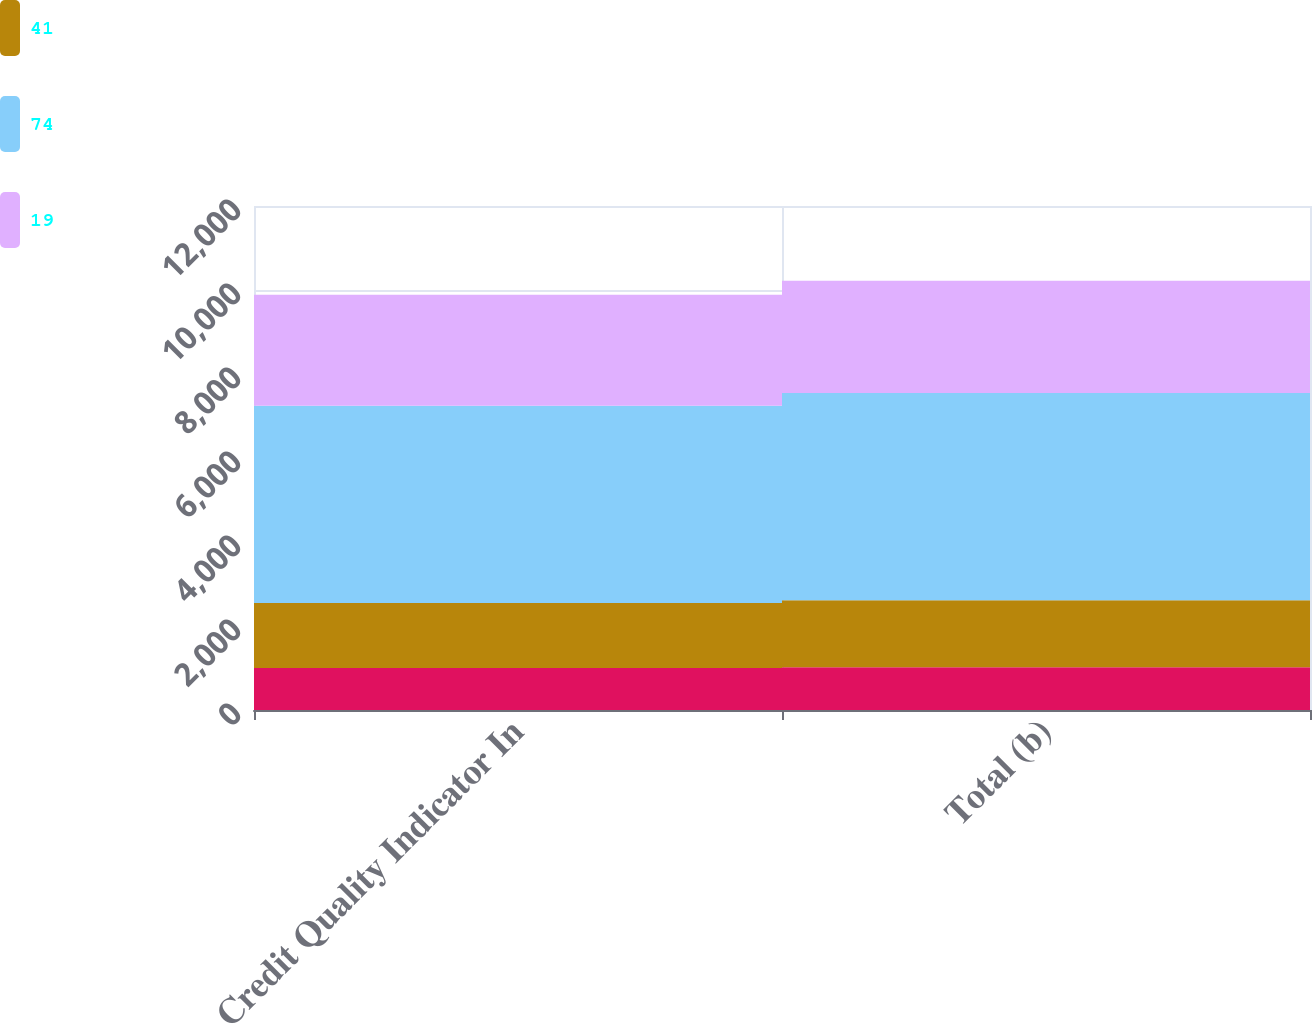Convert chart to OTSL. <chart><loc_0><loc_0><loc_500><loc_500><stacked_bar_chart><ecel><fcel>Credit Quality Indicator In<fcel>Total (b)<nl><fcel>nan<fcel>998<fcel>1016<nl><fcel>41<fcel>1549<fcel>1599<nl><fcel>74<fcel>4698<fcel>4935<nl><fcel>19<fcel>2640<fcel>2673<nl></chart> 